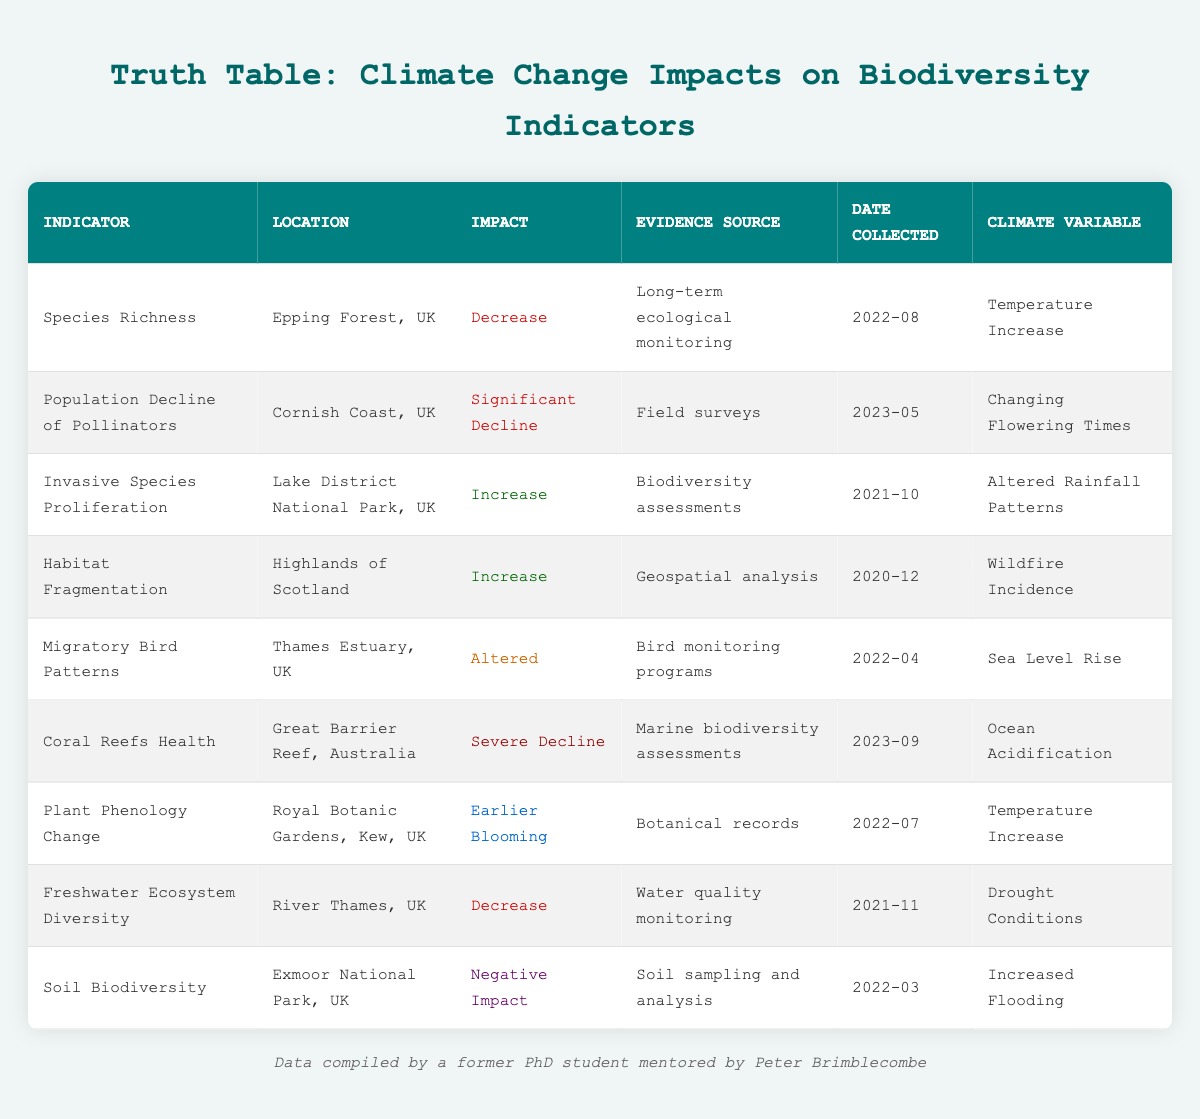What is the impact on 'Species Richness' in Epping Forest, UK? The table states that for 'Species Richness' in Epping Forest, UK, the impact is categorized as 'Decrease.'
Answer: Decrease Which location reports a 'Severe Decline' in coral reefs health? According to the table, 'Coral Reefs Health' reports a 'Severe Decline' specifically in the 'Great Barrier Reef, Australia.'
Answer: Great Barrier Reef, Australia How many indicators report a 'Negative Impact' due to climate change? From the table, only 'Soil Biodiversity' is noted to have a 'Negative Impact,' which means there is one indicator with that impact.
Answer: 1 Are there any indicators that indicate an 'Increase' in relation to climate change? The table shows two indicators: 'Invasive Species Proliferation' and 'Habitat Fragmentation,' both indicating an 'Increase.' Therefore, the answer is yes.
Answer: Yes What is the difference between the dates of data collection for 'Population Decline of Pollinators' and 'Freshwater Ecosystem Diversity'? 'Population Decline of Pollinators' is collected on '2023-05', while 'Freshwater Ecosystem Diversity' is collected on '2021-11.' To find the difference: 2023-05 (May 2023) minus 2021-11 (November 2021) results in a difference of 1 year and 6 months.
Answer: 1 year and 6 months Which climate variable is associated with 'Earlier Blooming'? In the table, 'Earlier Blooming' is associated with the climate variable 'Temperature Increase.'
Answer: Temperature Increase How many locations show a 'Decrease' in biodiversity indicators? Upon examining the table, 'Species Richness,' 'Freshwater Ecosystem Diversity,' and 'Population Decline of Pollinators' all indicate a decrease of some sort. There are three indicators showing a decrease.
Answer: 3 Do the climate variables affecting 'Coral Reefs Health' and 'Plant Phenology Change' include 'Temperature Increase'? 'Coral Reefs Health' is affected by 'Ocean Acidification,' and 'Plant Phenology Change' is affected by 'Temperature Increase.' Thus, they do not share the same climate variable, leading to a 'No.'
Answer: No What is the total number of indicators listed in the table? By counting the rows in the table, there are a total of nine indicators present.
Answer: 9 